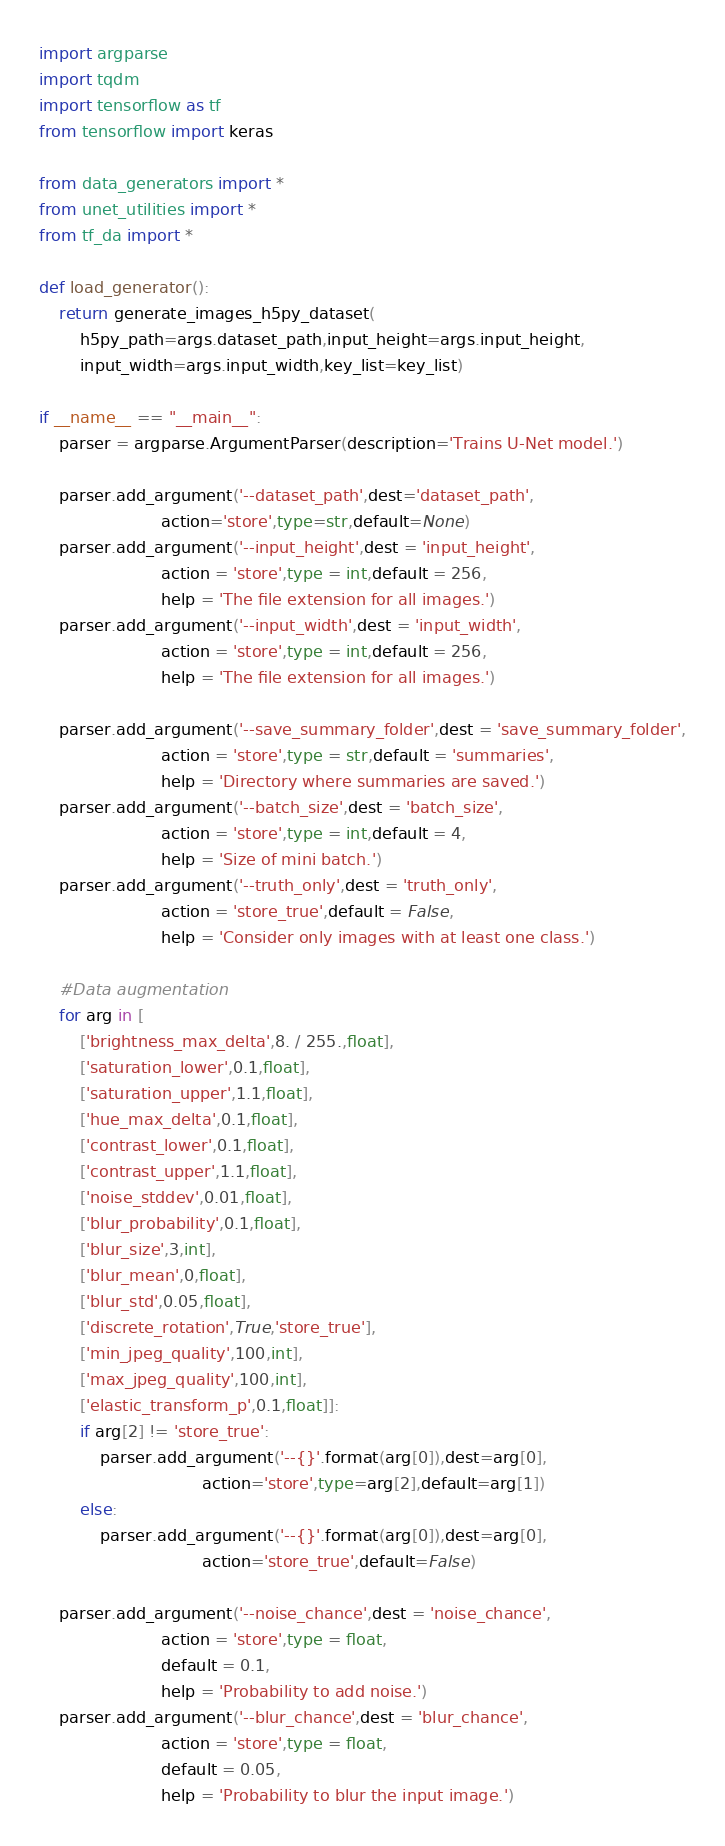<code> <loc_0><loc_0><loc_500><loc_500><_Python_>import argparse
import tqdm
import tensorflow as tf
from tensorflow import keras

from data_generators import *
from unet_utilities import *
from tf_da import *

def load_generator():
    return generate_images_h5py_dataset(
        h5py_path=args.dataset_path,input_height=args.input_height,
        input_width=args.input_width,key_list=key_list)

if __name__ == "__main__":
    parser = argparse.ArgumentParser(description='Trains U-Net model.')

    parser.add_argument('--dataset_path',dest='dataset_path',
                        action='store',type=str,default=None)
    parser.add_argument('--input_height',dest = 'input_height',
                        action = 'store',type = int,default = 256,
                        help = 'The file extension for all images.')
    parser.add_argument('--input_width',dest = 'input_width',
                        action = 'store',type = int,default = 256,
                        help = 'The file extension for all images.')

    parser.add_argument('--save_summary_folder',dest = 'save_summary_folder',
                        action = 'store',type = str,default = 'summaries',
                        help = 'Directory where summaries are saved.')
    parser.add_argument('--batch_size',dest = 'batch_size',
                        action = 'store',type = int,default = 4,
                        help = 'Size of mini batch.')
    parser.add_argument('--truth_only',dest = 'truth_only',
                        action = 'store_true',default = False,
                        help = 'Consider only images with at least one class.')

    #Data augmentation
    for arg in [
        ['brightness_max_delta',8. / 255.,float],
        ['saturation_lower',0.1,float],
        ['saturation_upper',1.1,float],
        ['hue_max_delta',0.1,float],
        ['contrast_lower',0.1,float],
        ['contrast_upper',1.1,float],
        ['noise_stddev',0.01,float],
        ['blur_probability',0.1,float],
        ['blur_size',3,int],
        ['blur_mean',0,float],
        ['blur_std',0.05,float],
        ['discrete_rotation',True,'store_true'],
        ['min_jpeg_quality',100,int],
        ['max_jpeg_quality',100,int],
        ['elastic_transform_p',0.1,float]]:
        if arg[2] != 'store_true':
            parser.add_argument('--{}'.format(arg[0]),dest=arg[0],
                                action='store',type=arg[2],default=arg[1])
        else:
            parser.add_argument('--{}'.format(arg[0]),dest=arg[0],
                                action='store_true',default=False)
    
    parser.add_argument('--noise_chance',dest = 'noise_chance',
                        action = 'store',type = float,
                        default = 0.1,
                        help = 'Probability to add noise.')
    parser.add_argument('--blur_chance',dest = 'blur_chance',
                        action = 'store',type = float,
                        default = 0.05,
                        help = 'Probability to blur the input image.')</code> 